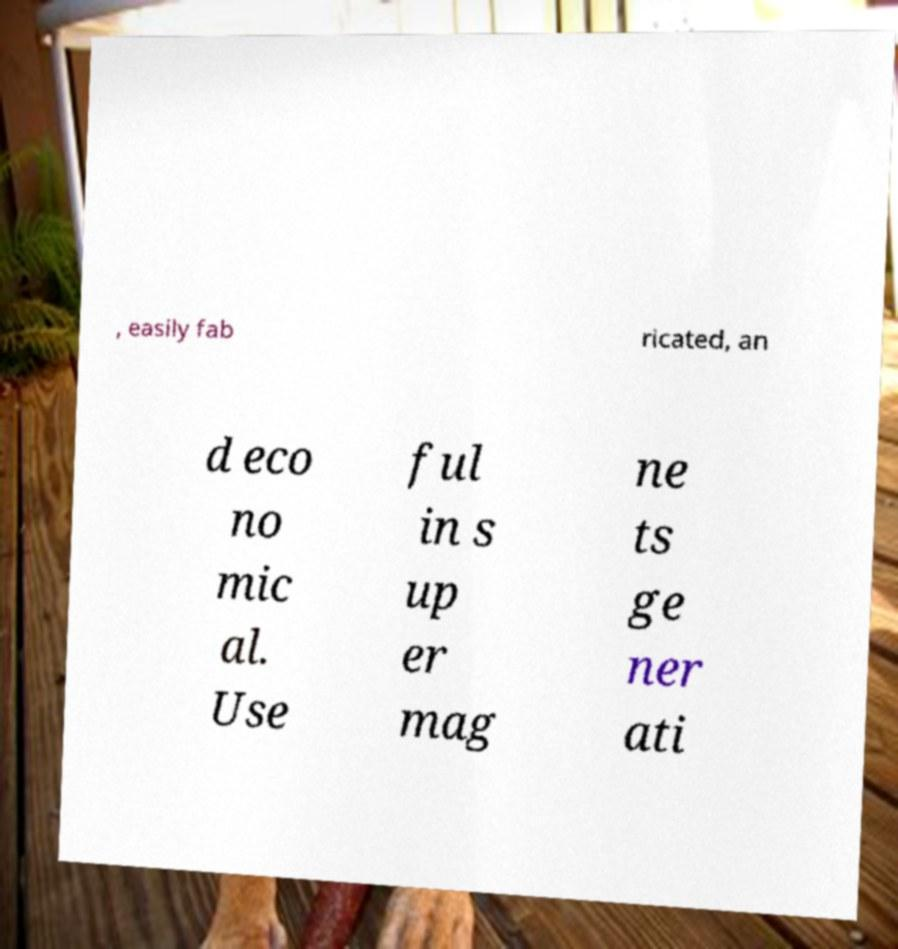I need the written content from this picture converted into text. Can you do that? , easily fab ricated, an d eco no mic al. Use ful in s up er mag ne ts ge ner ati 